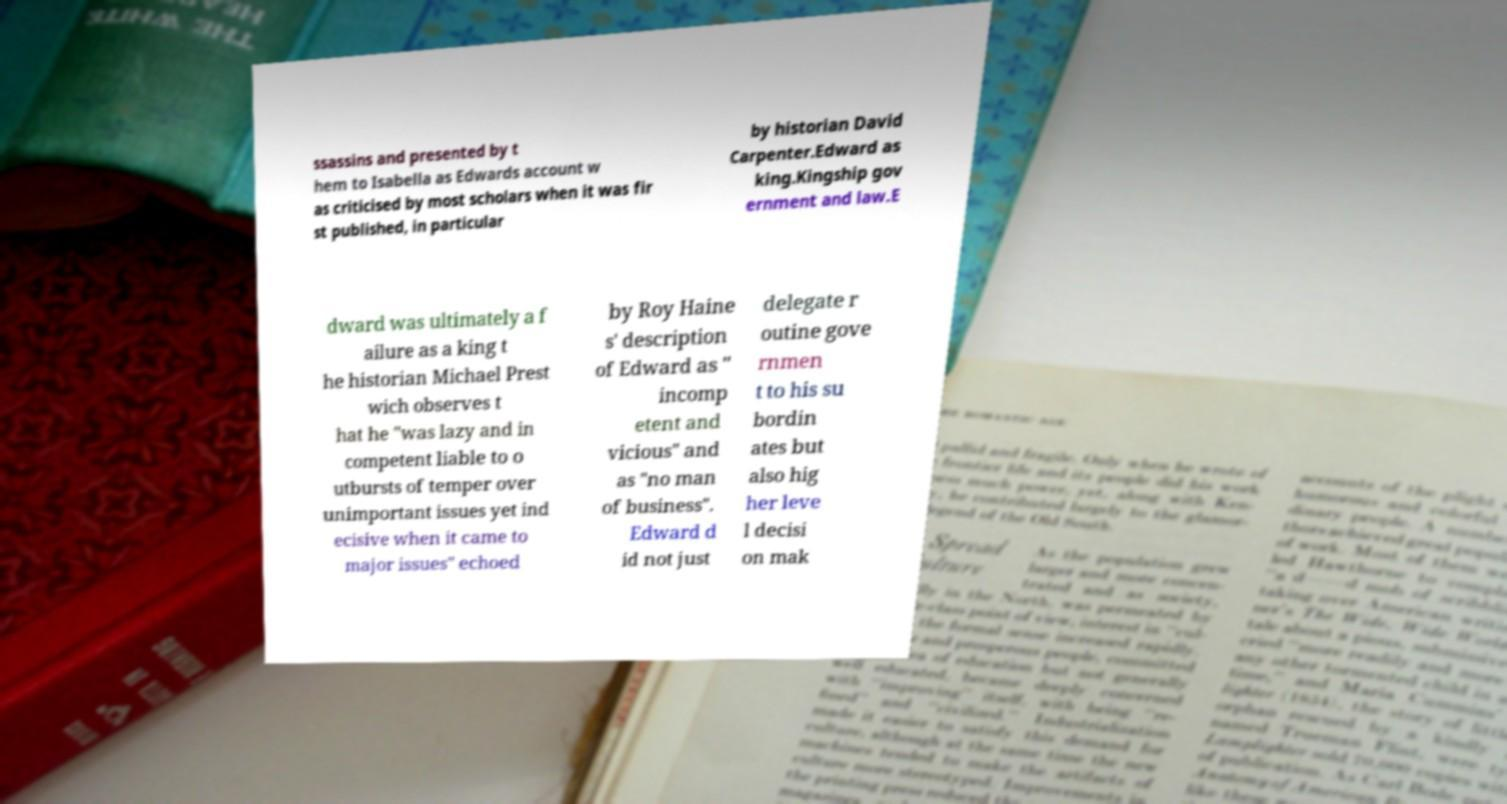Can you read and provide the text displayed in the image?This photo seems to have some interesting text. Can you extract and type it out for me? ssassins and presented by t hem to Isabella as Edwards account w as criticised by most scholars when it was fir st published, in particular by historian David Carpenter.Edward as king.Kingship gov ernment and law.E dward was ultimately a f ailure as a king t he historian Michael Prest wich observes t hat he "was lazy and in competent liable to o utbursts of temper over unimportant issues yet ind ecisive when it came to major issues" echoed by Roy Haine s' description of Edward as " incomp etent and vicious" and as "no man of business". Edward d id not just delegate r outine gove rnmen t to his su bordin ates but also hig her leve l decisi on mak 